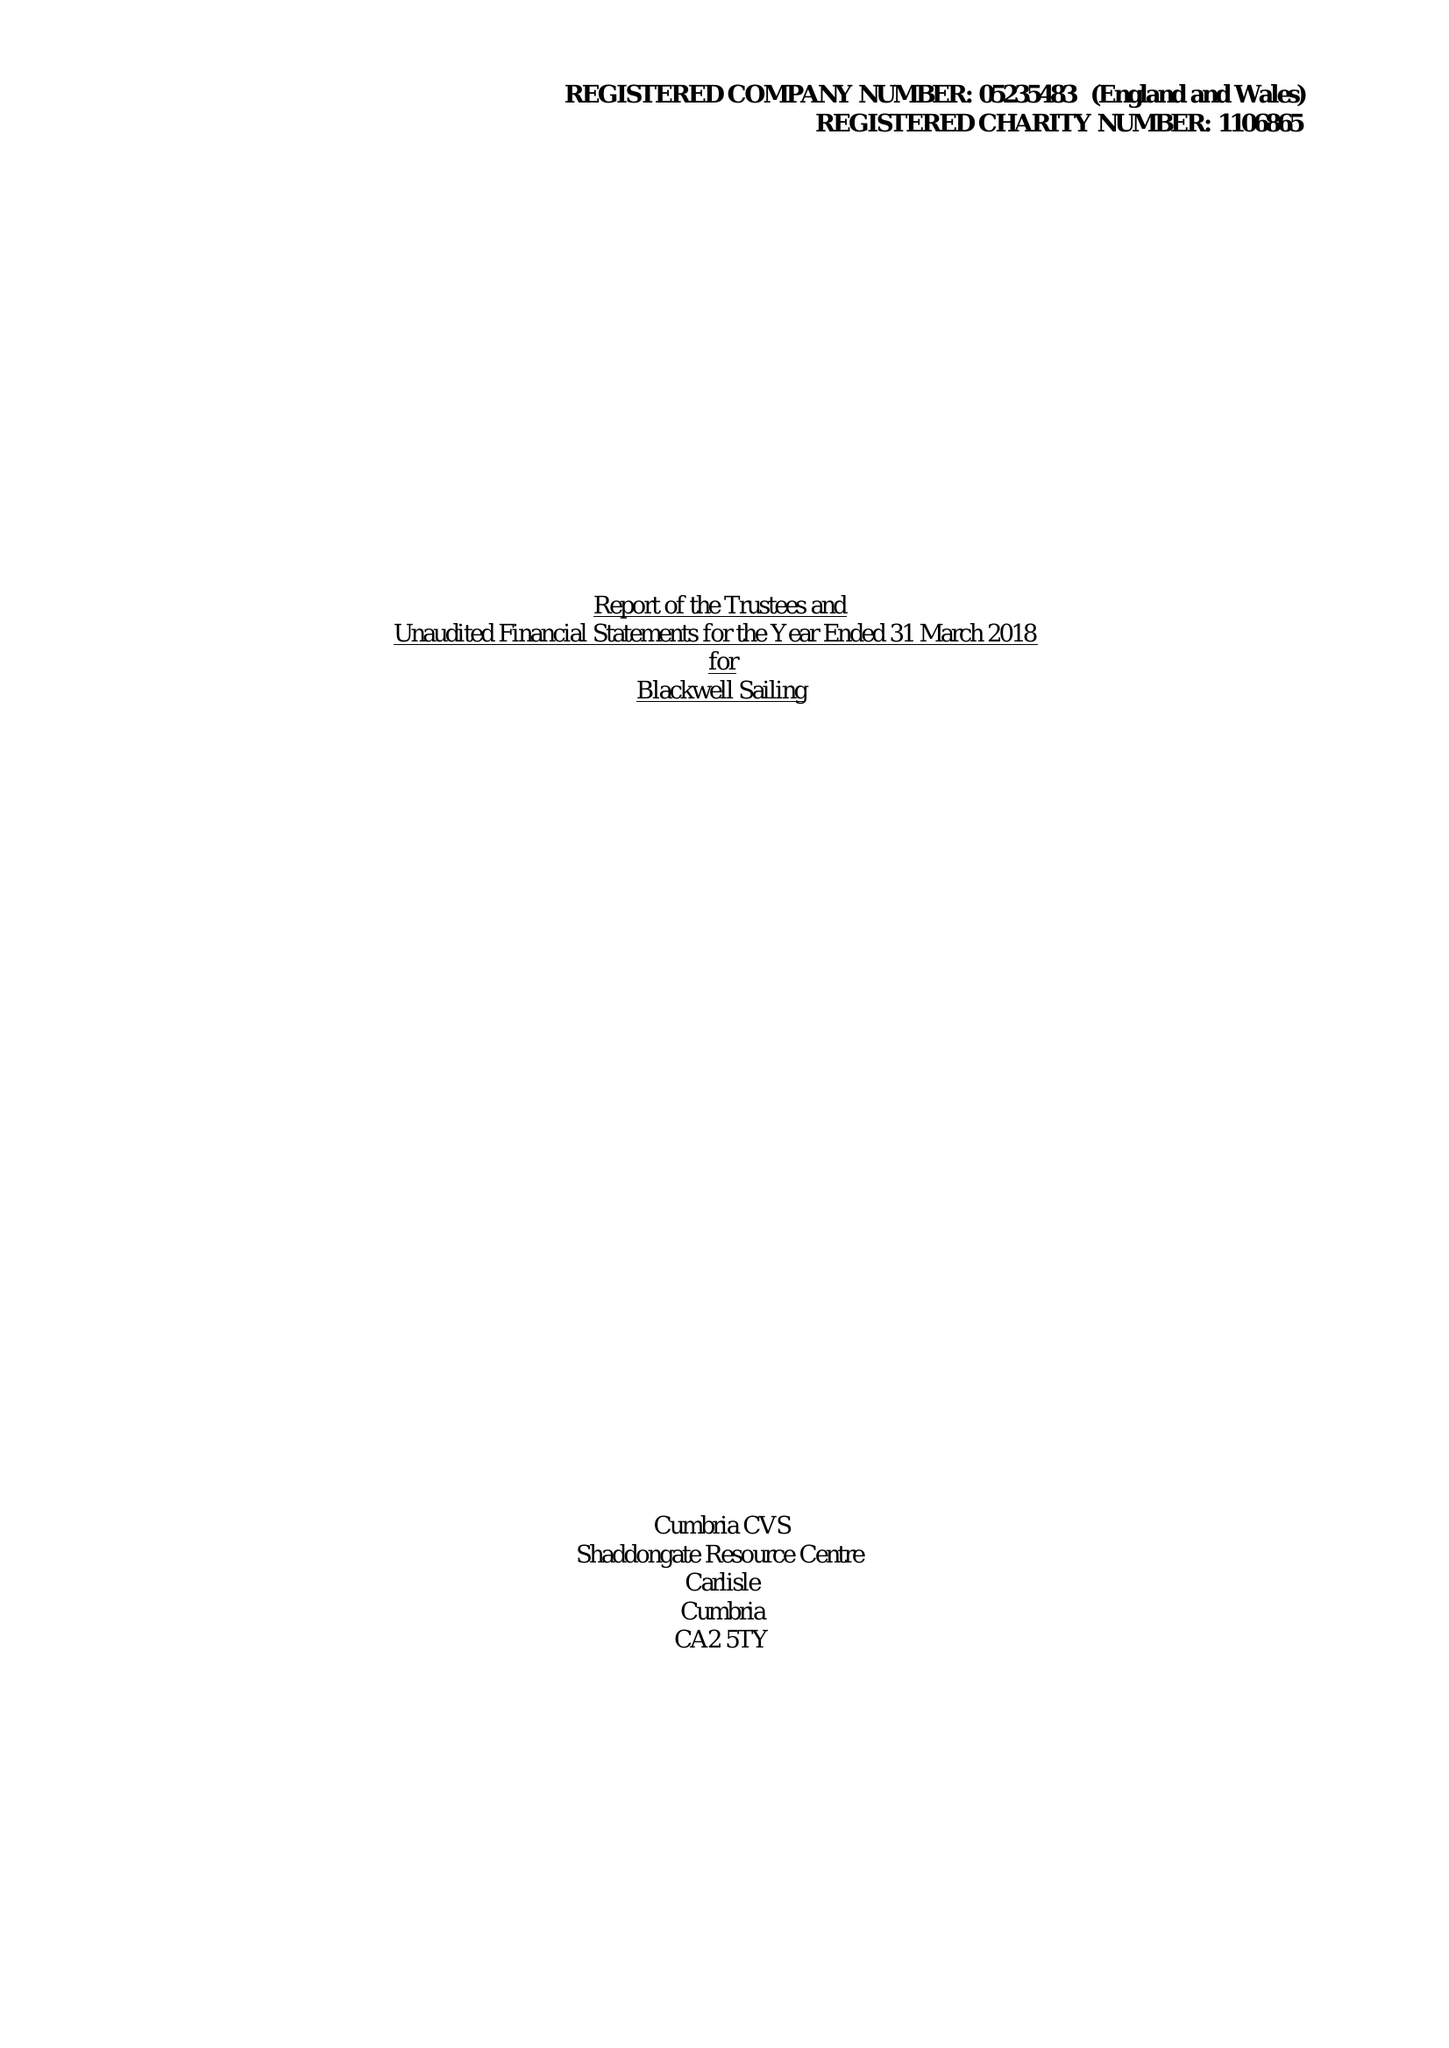What is the value for the report_date?
Answer the question using a single word or phrase. 2018-03-31 